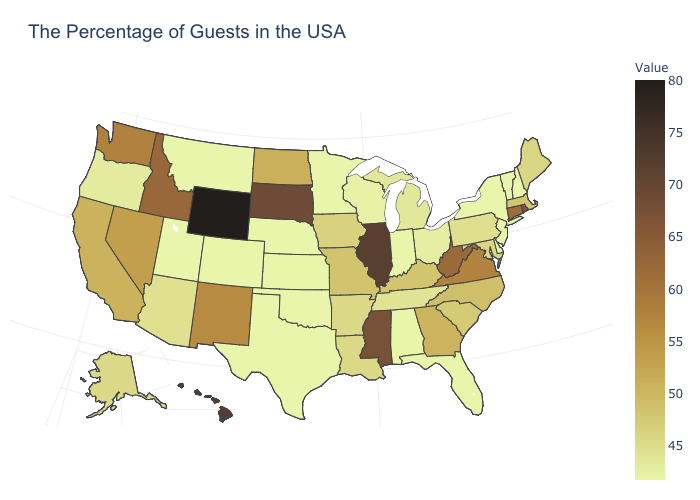Among the states that border Washington , does Oregon have the lowest value?
Be succinct. Yes. Does New York have a higher value than Illinois?
Keep it brief. No. Does Minnesota have the highest value in the MidWest?
Short answer required. No. Does Wyoming have the highest value in the USA?
Concise answer only. Yes. Does Mississippi have a lower value than Illinois?
Write a very short answer. Yes. 